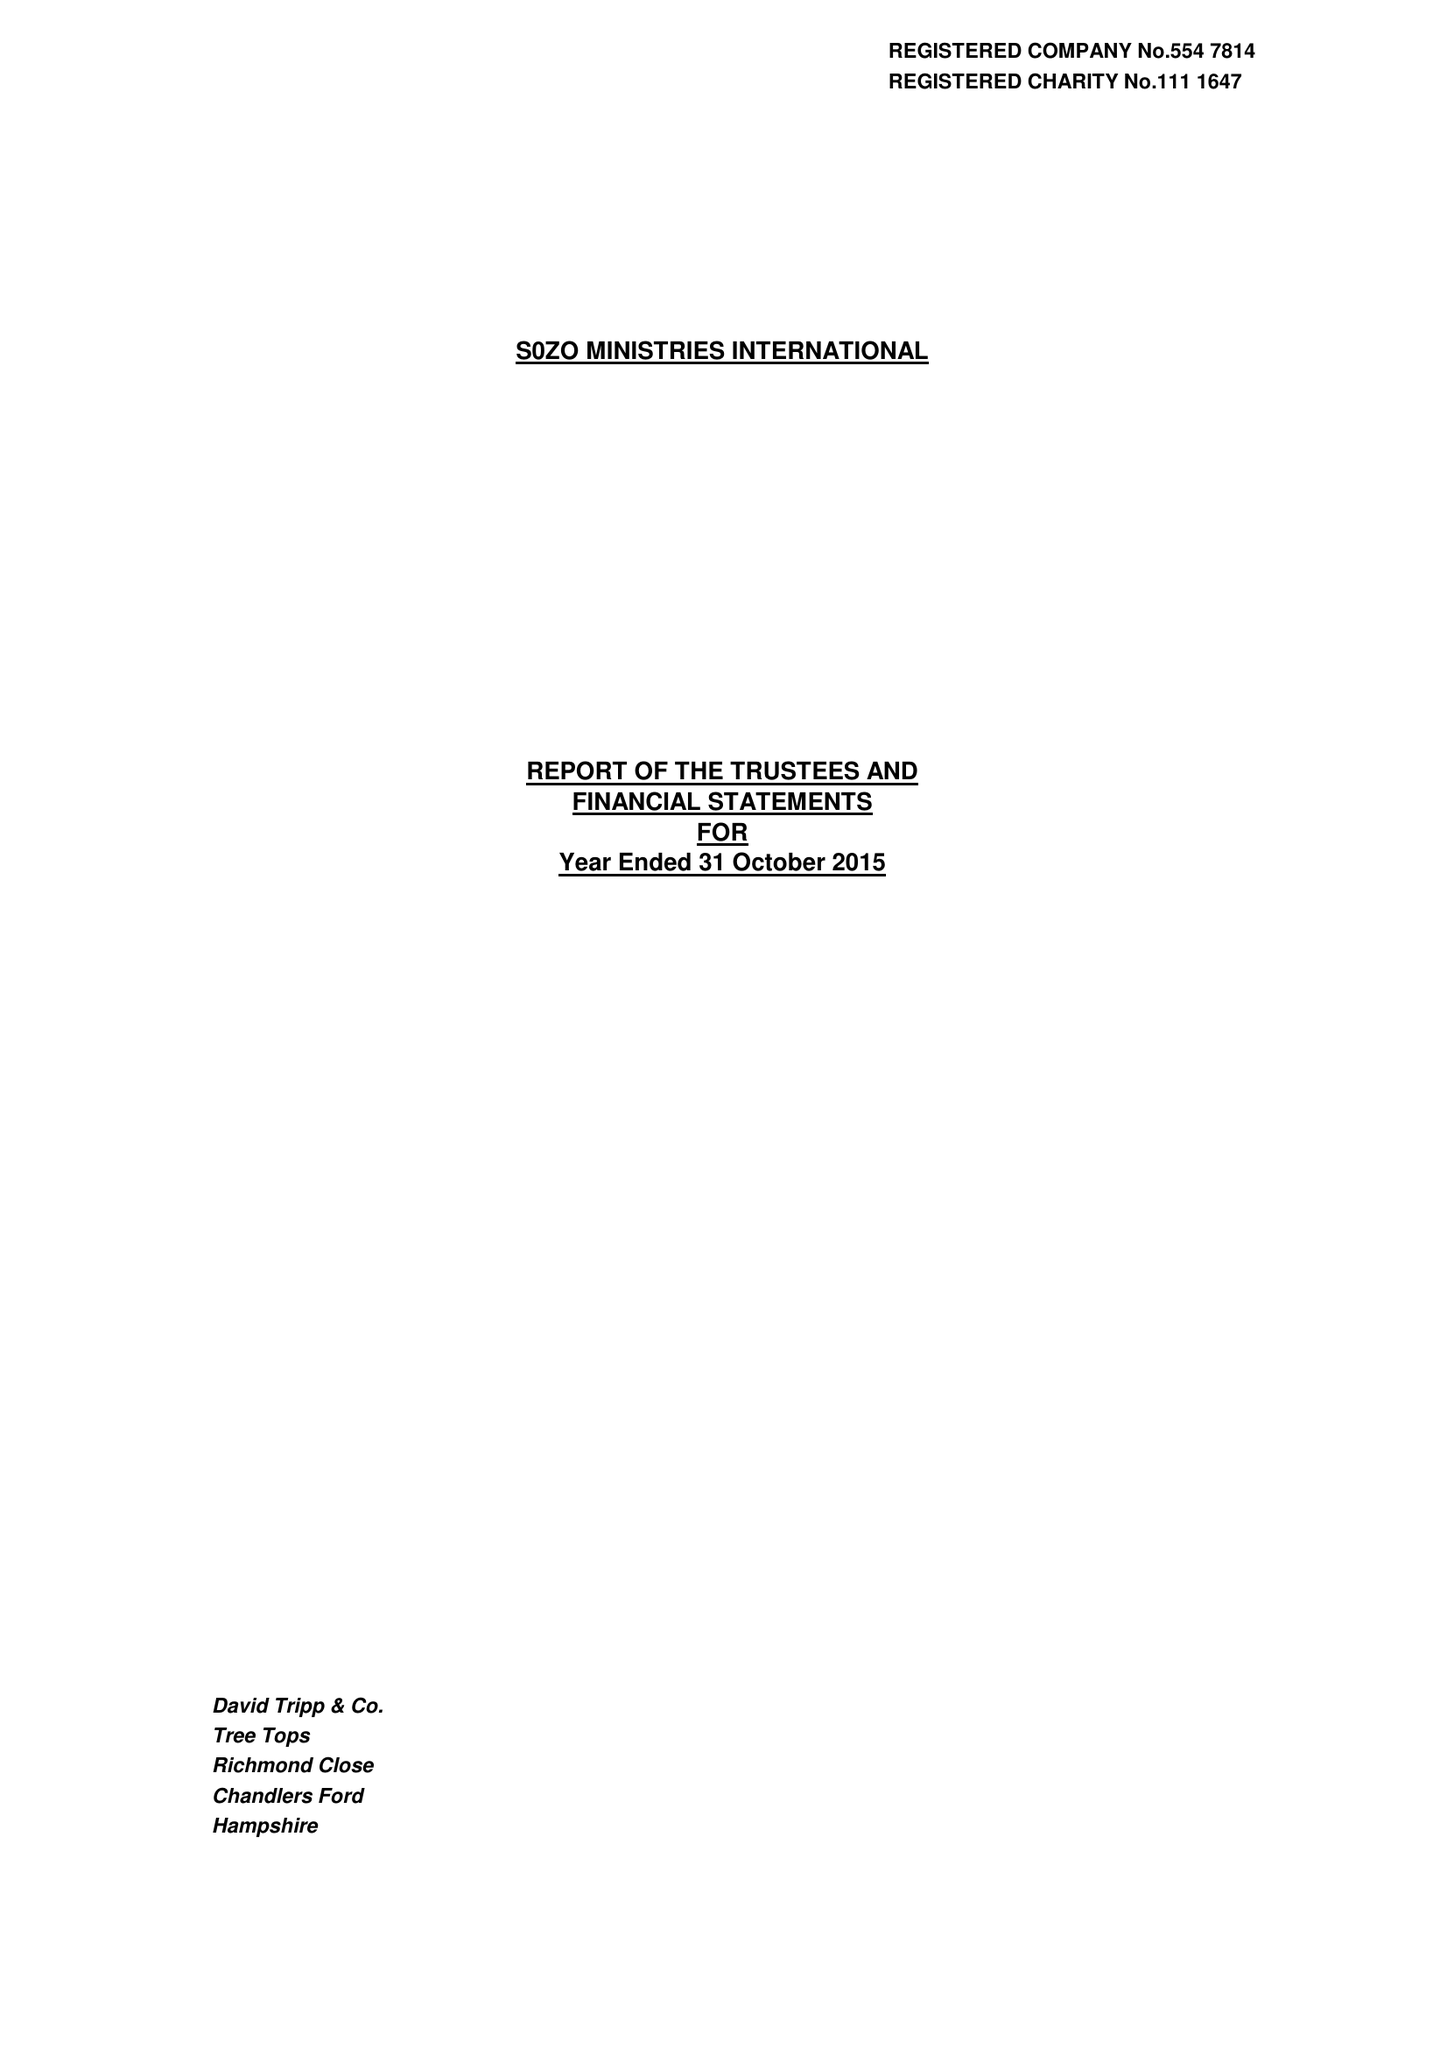What is the value for the charity_name?
Answer the question using a single word or phrase. Sozo Ministries International 